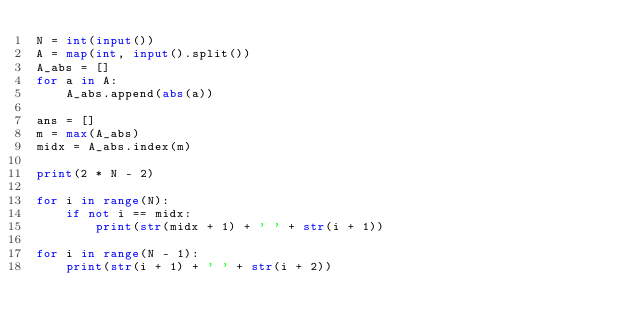<code> <loc_0><loc_0><loc_500><loc_500><_Python_>N = int(input())
A = map(int, input().split())
A_abs = []
for a in A:
    A_abs.append(abs(a))

ans = []
m = max(A_abs)
midx = A_abs.index(m)

print(2 * N - 2)

for i in range(N):
    if not i == midx:
        print(str(midx + 1) + ' ' + str(i + 1))

for i in range(N - 1):
    print(str(i + 1) + ' ' + str(i + 2))
</code> 